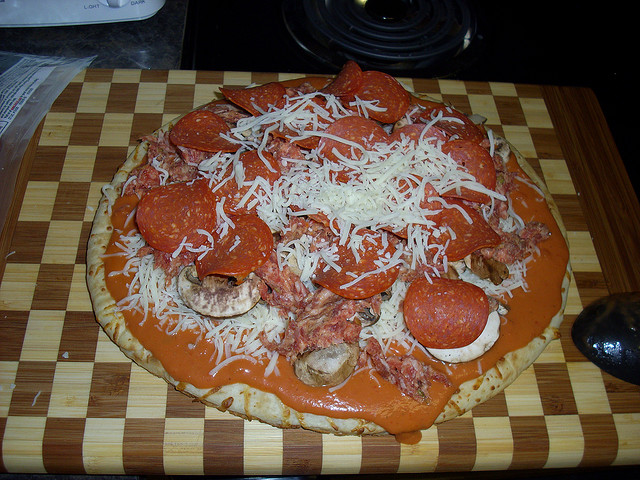<image>What color is the mat? I am not sure about the color of the mat. It could be brown, red, yellow and brown, or even tan. What color is the mat? I am not sure what color the mat is. It can be seen as brown or red. 